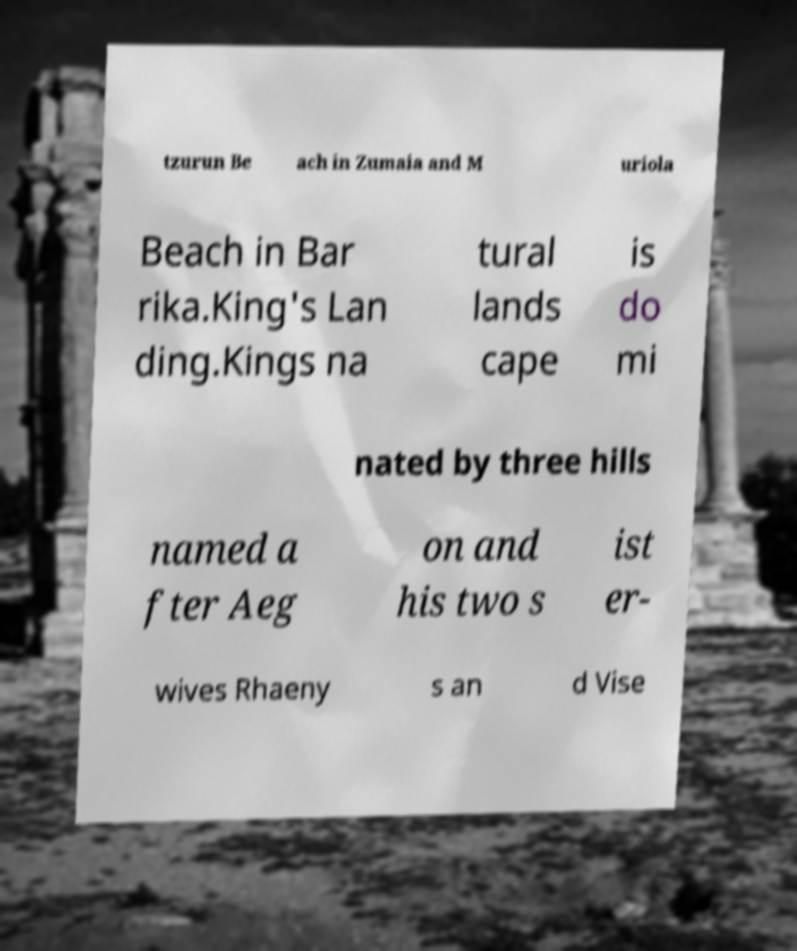Can you accurately transcribe the text from the provided image for me? tzurun Be ach in Zumaia and M uriola Beach in Bar rika.King's Lan ding.Kings na tural lands cape is do mi nated by three hills named a fter Aeg on and his two s ist er- wives Rhaeny s an d Vise 